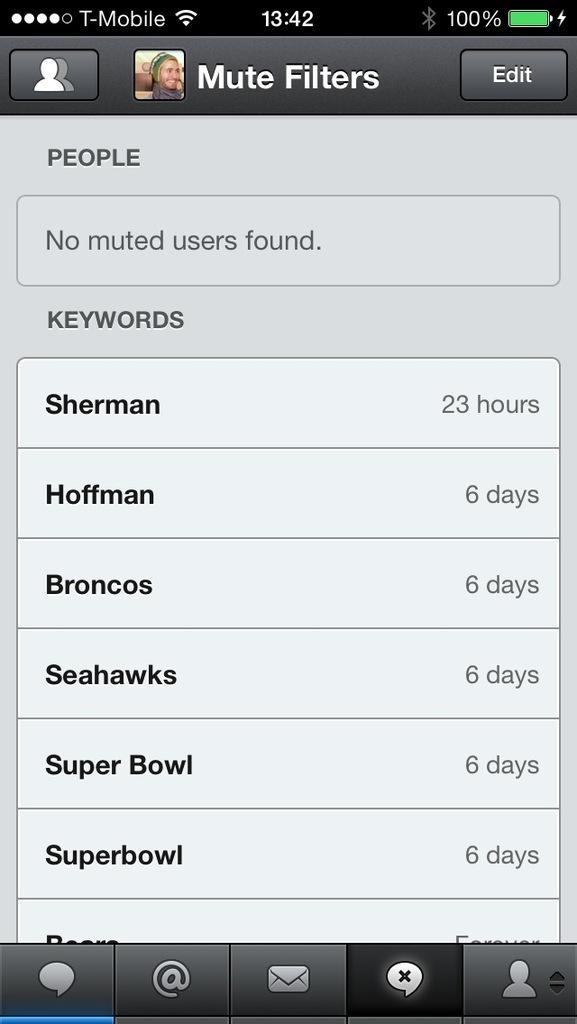<image>
Render a clear and concise summary of the photo. A phone page with the keywords of Sherman, Hoffman, Broncos, Seahawks, Super Bowl, Superbowl. 